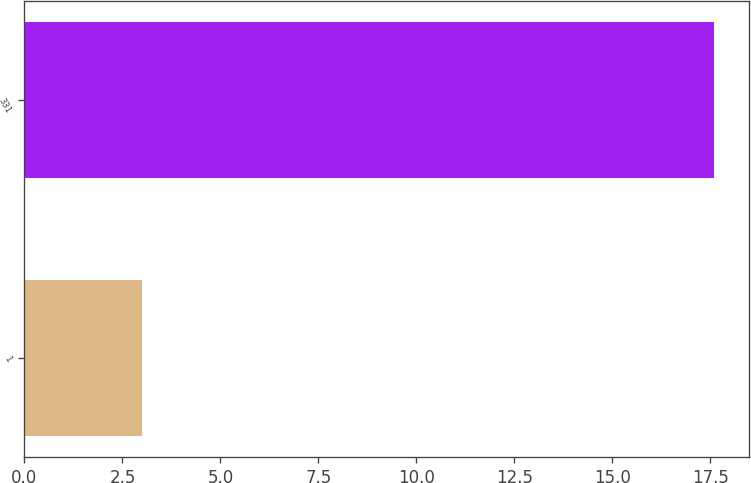Convert chart to OTSL. <chart><loc_0><loc_0><loc_500><loc_500><bar_chart><fcel>1<fcel>331<nl><fcel>3<fcel>17.6<nl></chart> 